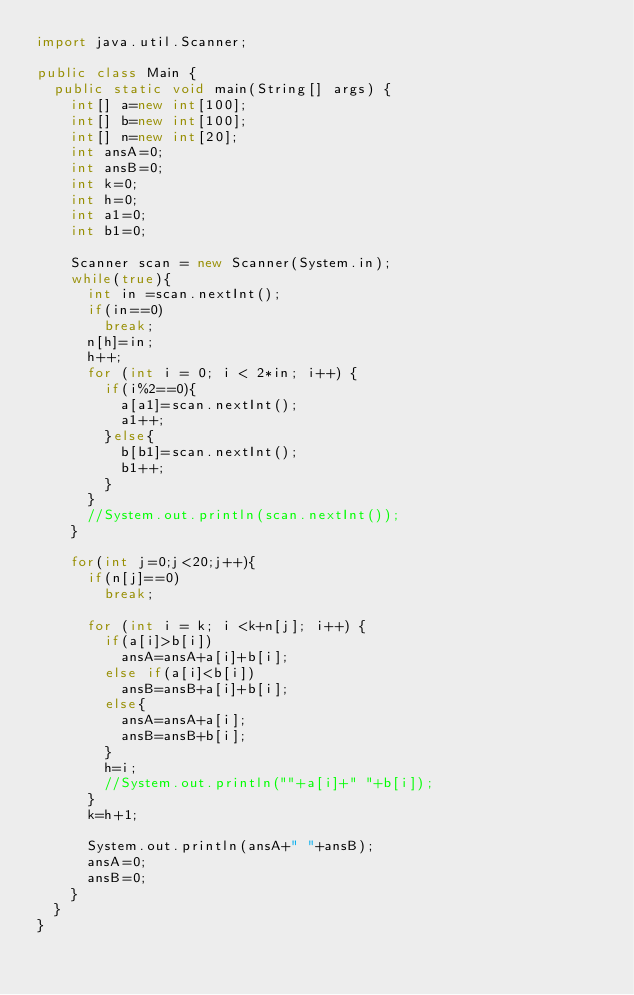<code> <loc_0><loc_0><loc_500><loc_500><_Java_>import java.util.Scanner;

public class Main {
	public static void main(String[] args) {
		int[] a=new int[100];
		int[] b=new int[100];
		int[] n=new int[20];
		int ansA=0;
		int ansB=0;
		int k=0;
		int h=0;
		int a1=0;
		int b1=0;
		
		Scanner scan = new Scanner(System.in);
		while(true){
			int in =scan.nextInt();
			if(in==0)
				break;
			n[h]=in;
			h++;
			for (int i = 0; i < 2*in; i++) {
				if(i%2==0){
					a[a1]=scan.nextInt();
					a1++;
				}else{
					b[b1]=scan.nextInt();
					b1++;
				}
			}
			//System.out.println(scan.nextInt());
		}
	
		for(int j=0;j<20;j++){
			if(n[j]==0)
				break;
			
			for (int i = k; i <k+n[j]; i++) {
				if(a[i]>b[i])
					ansA=ansA+a[i]+b[i];
				else if(a[i]<b[i])
					ansB=ansB+a[i]+b[i];
				else{	
					ansA=ansA+a[i];
					ansB=ansB+b[i];
				}
				h=i;
				//System.out.println(""+a[i]+" "+b[i]);
			}
			k=h+1;
			
			System.out.println(ansA+" "+ansB);
			ansA=0;
			ansB=0;
		}		
	}
}</code> 